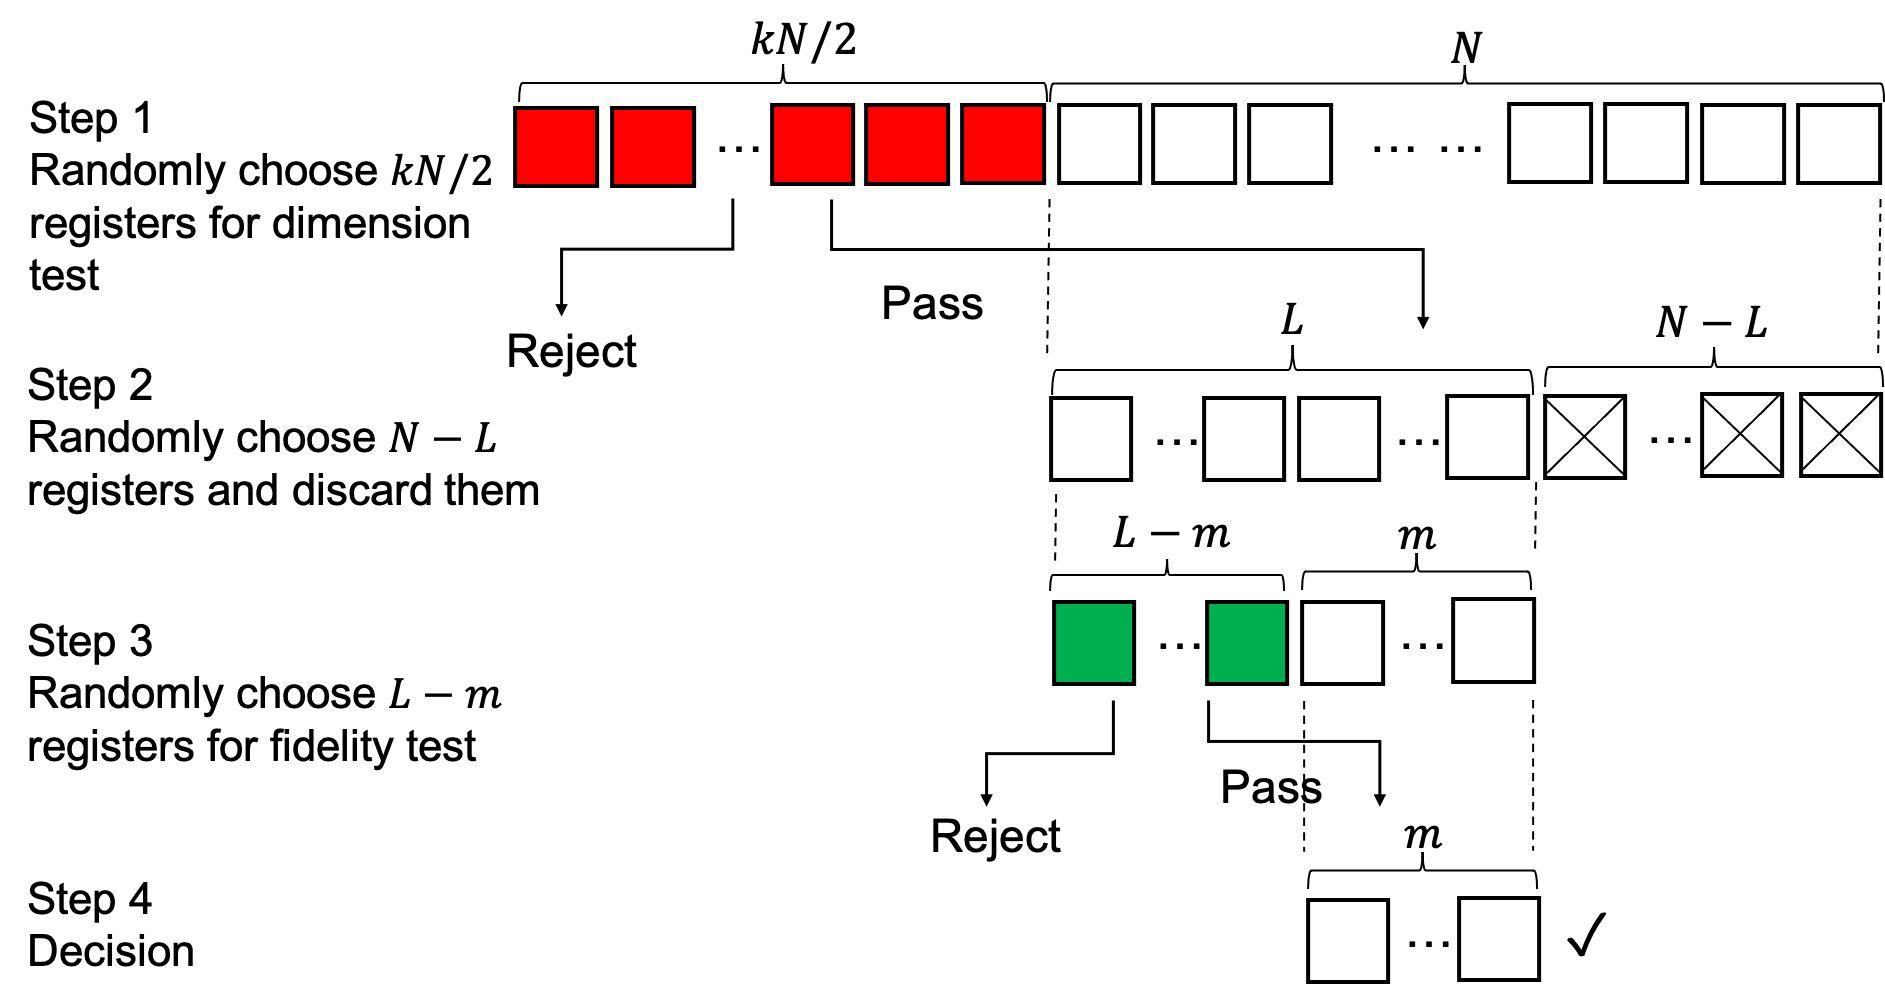What happens in the final step, and how is the decision made? In the final step, Step 4, a decision is made about the final selection of registers that have passed all previous tests. The decision-making process isn't detailed in the image, but it typically involves a comprehensive evaluation of the remaining candidates against the desired specifications or requirements. At this juncture, the best-performing registers according to the fidelity and dimension tests are likely chosen for their intended application or for further development. This crucial step finalizes the stringent selection process by formally accepting the registers that have consistently demonstrated their suitability throughout the rigorous testing phases. 